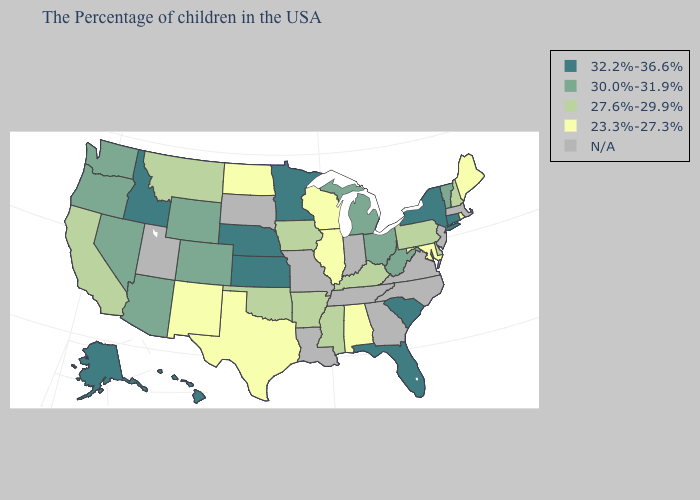How many symbols are there in the legend?
Quick response, please. 5. What is the lowest value in the USA?
Keep it brief. 23.3%-27.3%. What is the lowest value in the USA?
Quick response, please. 23.3%-27.3%. Name the states that have a value in the range 23.3%-27.3%?
Keep it brief. Maine, Rhode Island, Maryland, Alabama, Wisconsin, Illinois, Texas, North Dakota, New Mexico. Among the states that border Louisiana , which have the highest value?
Answer briefly. Mississippi, Arkansas. Among the states that border Illinois , which have the highest value?
Give a very brief answer. Kentucky, Iowa. Name the states that have a value in the range N/A?
Be succinct. Massachusetts, New Jersey, Virginia, North Carolina, Georgia, Indiana, Tennessee, Louisiana, Missouri, South Dakota, Utah. Which states have the lowest value in the USA?
Answer briefly. Maine, Rhode Island, Maryland, Alabama, Wisconsin, Illinois, Texas, North Dakota, New Mexico. Among the states that border New Hampshire , does Maine have the highest value?
Short answer required. No. Name the states that have a value in the range 27.6%-29.9%?
Short answer required. New Hampshire, Delaware, Pennsylvania, Kentucky, Mississippi, Arkansas, Iowa, Oklahoma, Montana, California. Which states hav the highest value in the MidWest?
Be succinct. Minnesota, Kansas, Nebraska. Name the states that have a value in the range 30.0%-31.9%?
Keep it brief. Vermont, West Virginia, Ohio, Michigan, Wyoming, Colorado, Arizona, Nevada, Washington, Oregon. What is the lowest value in the Northeast?
Concise answer only. 23.3%-27.3%. What is the value of Tennessee?
Concise answer only. N/A. Does New Mexico have the lowest value in the West?
Be succinct. Yes. 